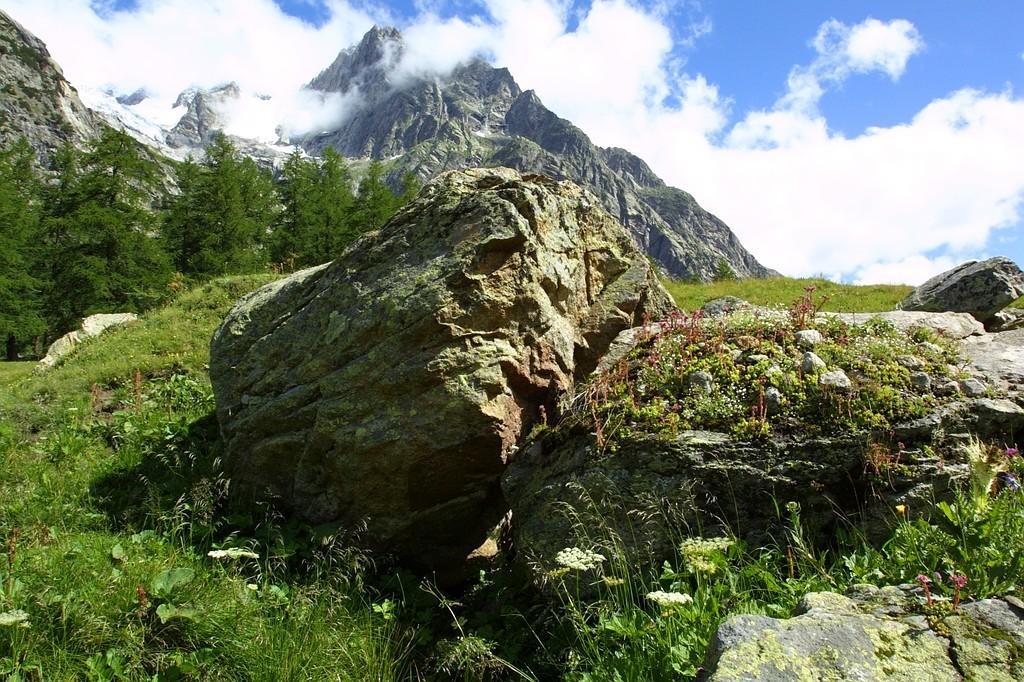Could you give a brief overview of what you see in this image? In the image we can see there is a ground covered with grass and plants. There are rocks on the ground and behind there are trees. There are mountains and there is a cloudy sky. 